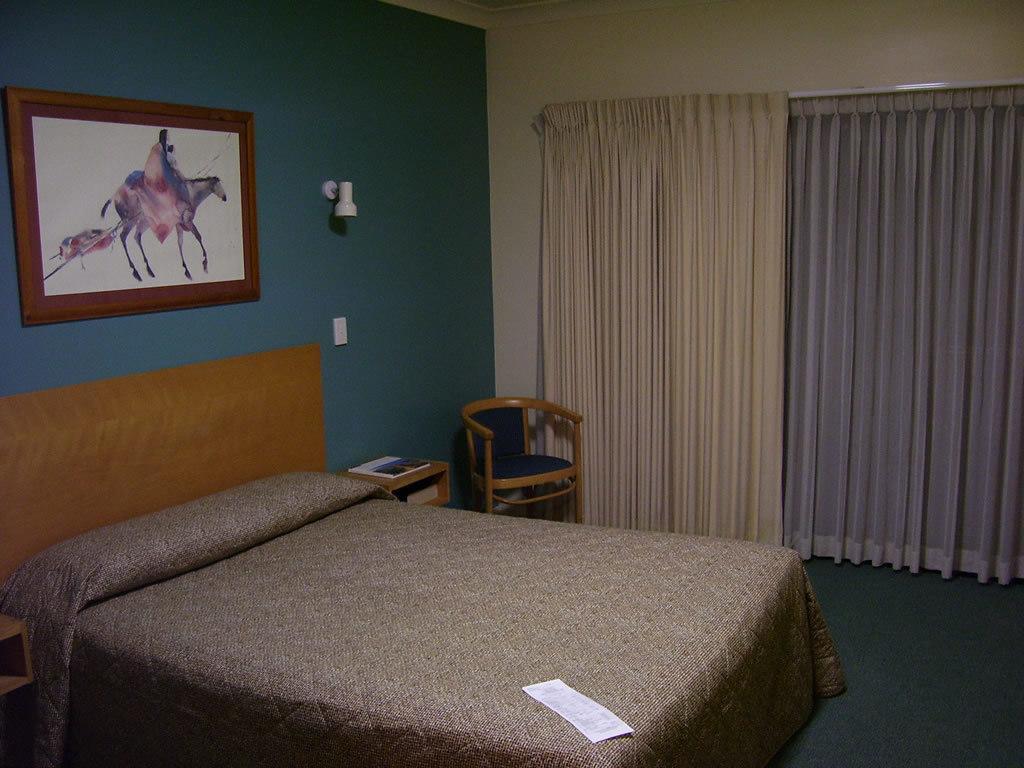Please provide a concise description of this image. In this image we can see the inner view of a room. In the room there are cot with quilt on it, chair, side table, switch board, electric light, wall hanging attached to the wall and curtains. 